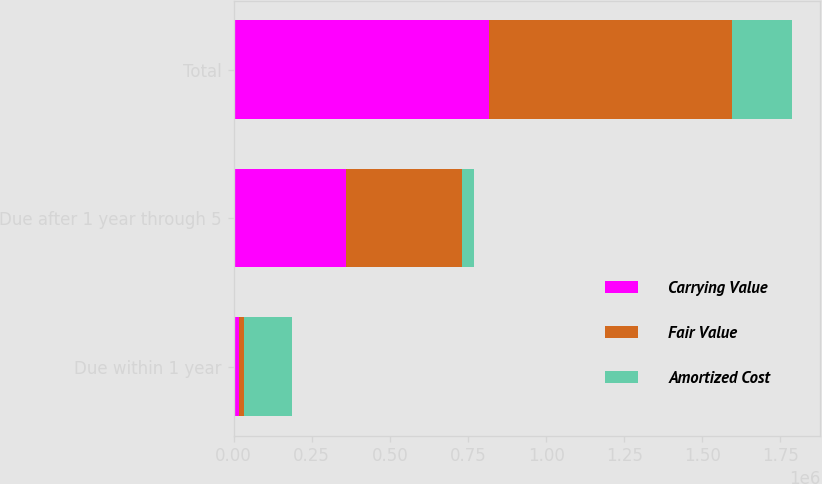<chart> <loc_0><loc_0><loc_500><loc_500><stacked_bar_chart><ecel><fcel>Due within 1 year<fcel>Due after 1 year through 5<fcel>Total<nl><fcel>Carrying Value<fcel>16103<fcel>361050<fcel>816161<nl><fcel>Fair Value<fcel>16196<fcel>370851<fcel>779855<nl><fcel>Amortized Cost<fcel>154000<fcel>37450<fcel>191450<nl></chart> 